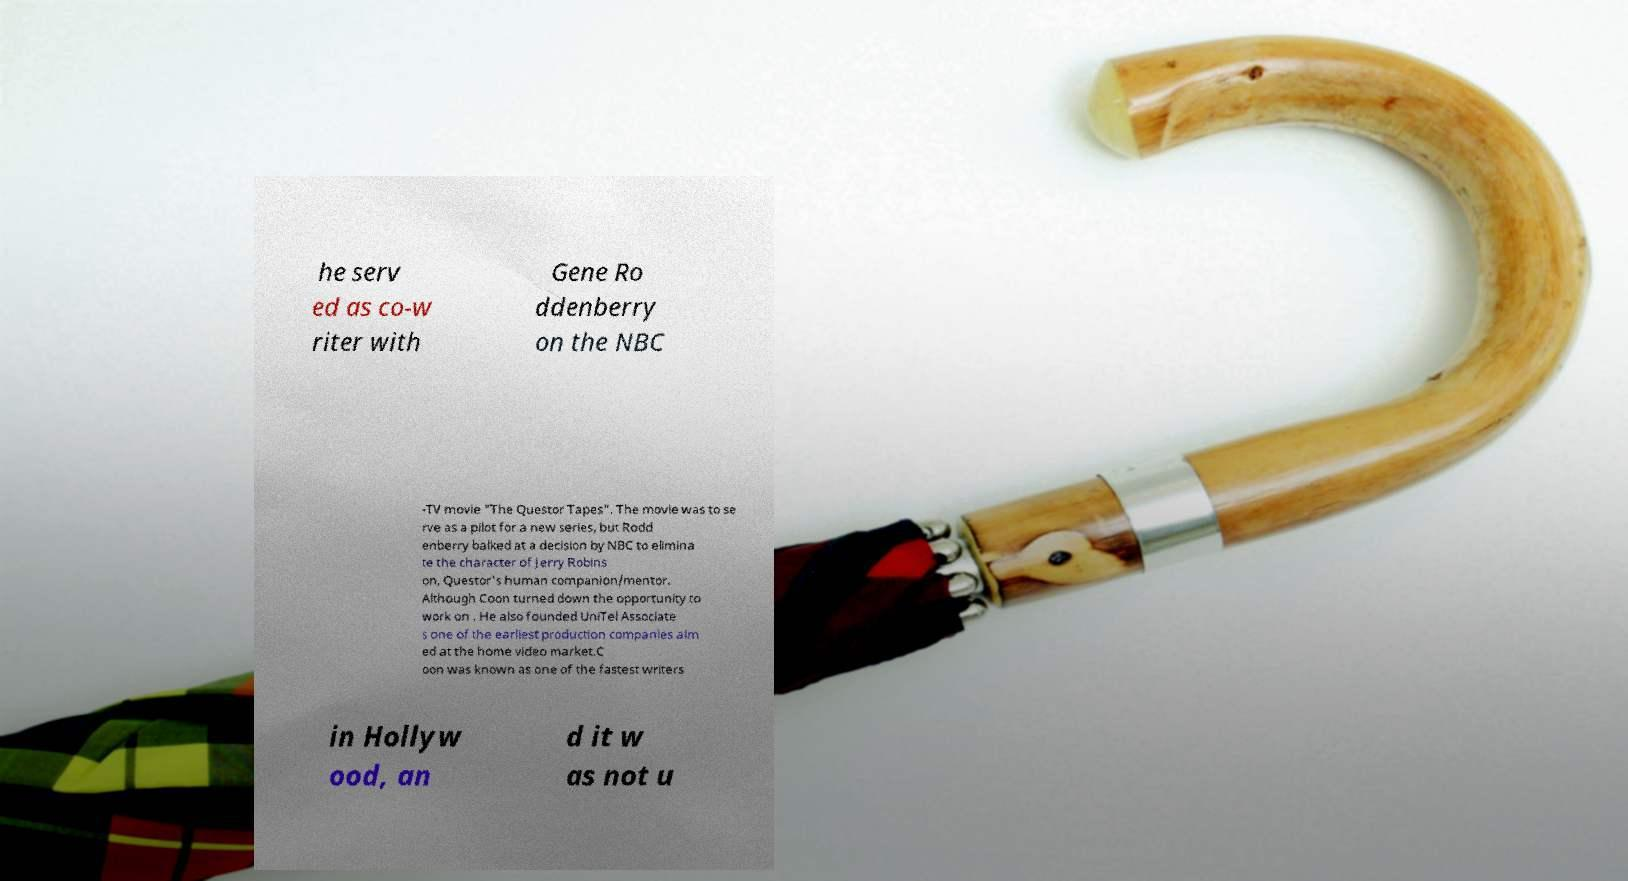Please read and relay the text visible in this image. What does it say? he serv ed as co-w riter with Gene Ro ddenberry on the NBC -TV movie "The Questor Tapes". The movie was to se rve as a pilot for a new series, but Rodd enberry balked at a decision by NBC to elimina te the character of Jerry Robins on, Questor's human companion/mentor. Although Coon turned down the opportunity to work on . He also founded UniTel Associate s one of the earliest production companies aim ed at the home video market.C oon was known as one of the fastest writers in Hollyw ood, an d it w as not u 